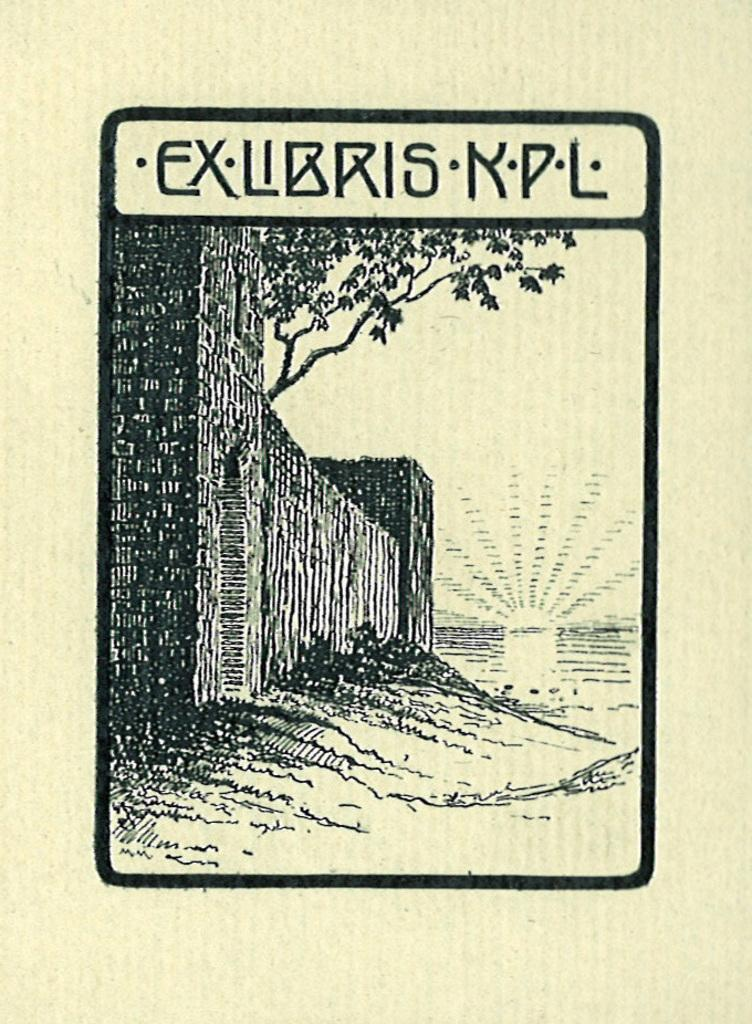What is featured in the image? There is a poster in the image. What elements are included in the poster? The poster contains a wall and a tree. Is there any text on the poster? Yes, there is text on the poster. What type of apparel is the tree wearing in the image? There is no apparel present in the image, as the tree is a part of the poster and not a living entity. 